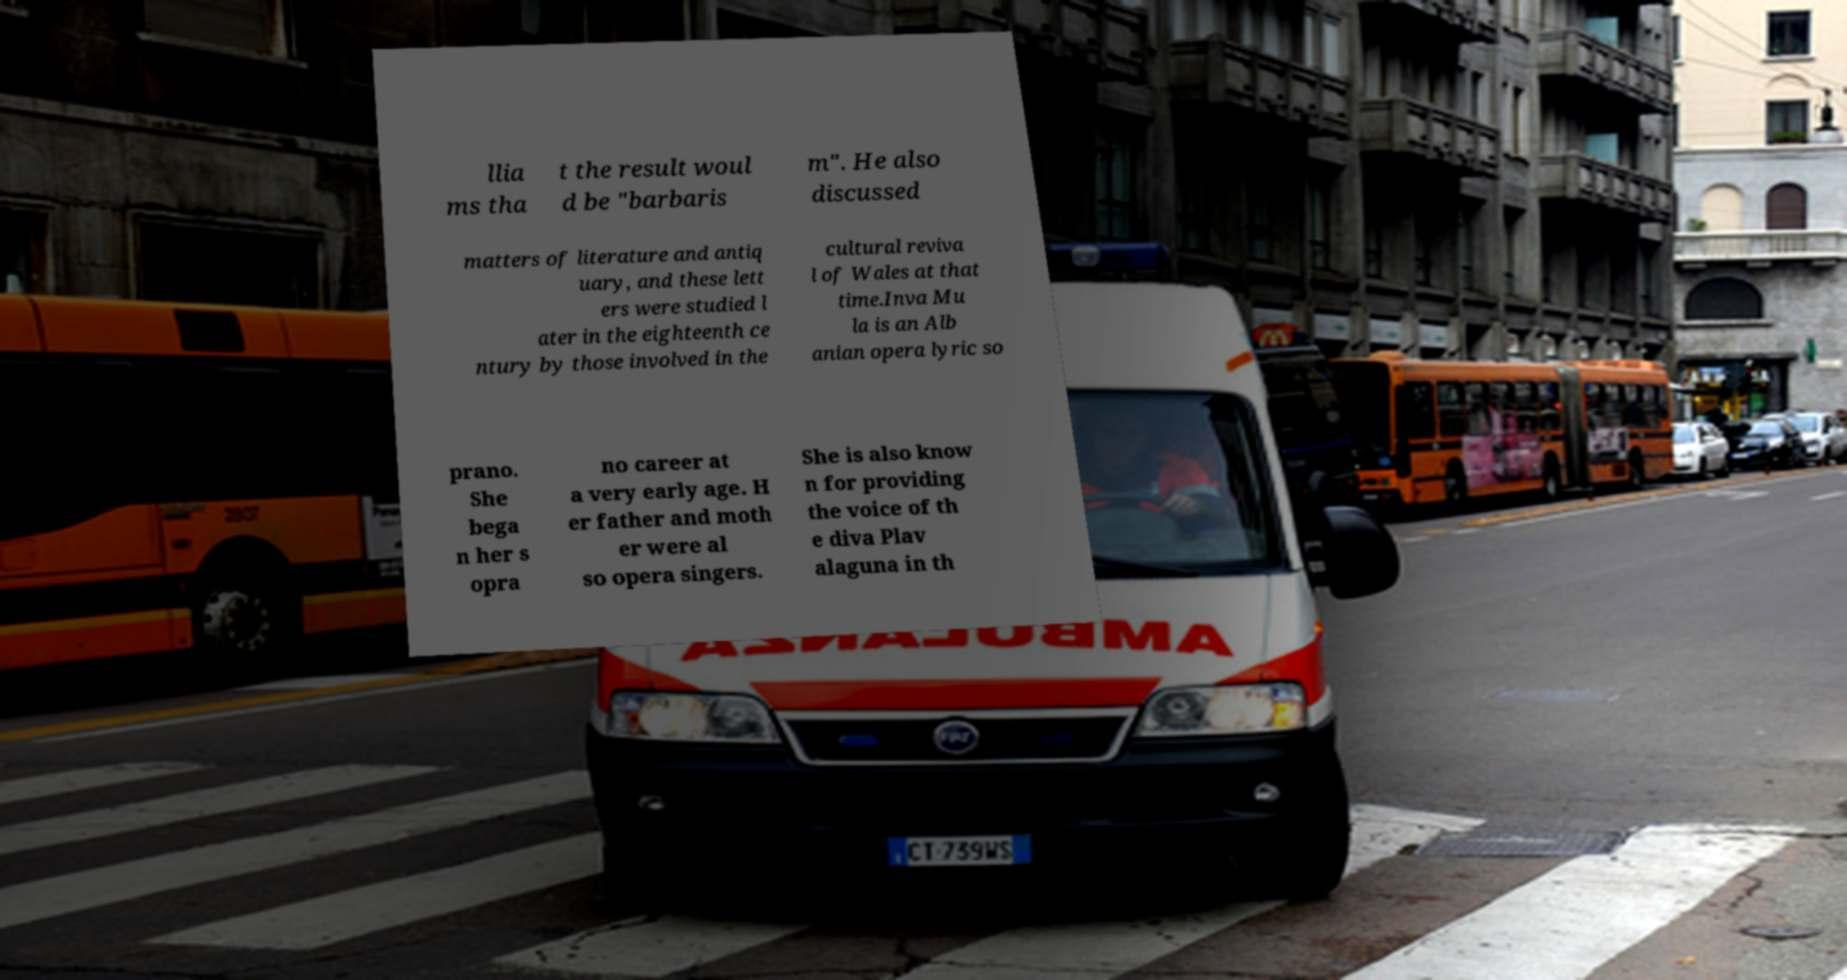Please read and relay the text visible in this image. What does it say? llia ms tha t the result woul d be "barbaris m". He also discussed matters of literature and antiq uary, and these lett ers were studied l ater in the eighteenth ce ntury by those involved in the cultural reviva l of Wales at that time.Inva Mu la is an Alb anian opera lyric so prano. She bega n her s opra no career at a very early age. H er father and moth er were al so opera singers. She is also know n for providing the voice of th e diva Plav alaguna in th 